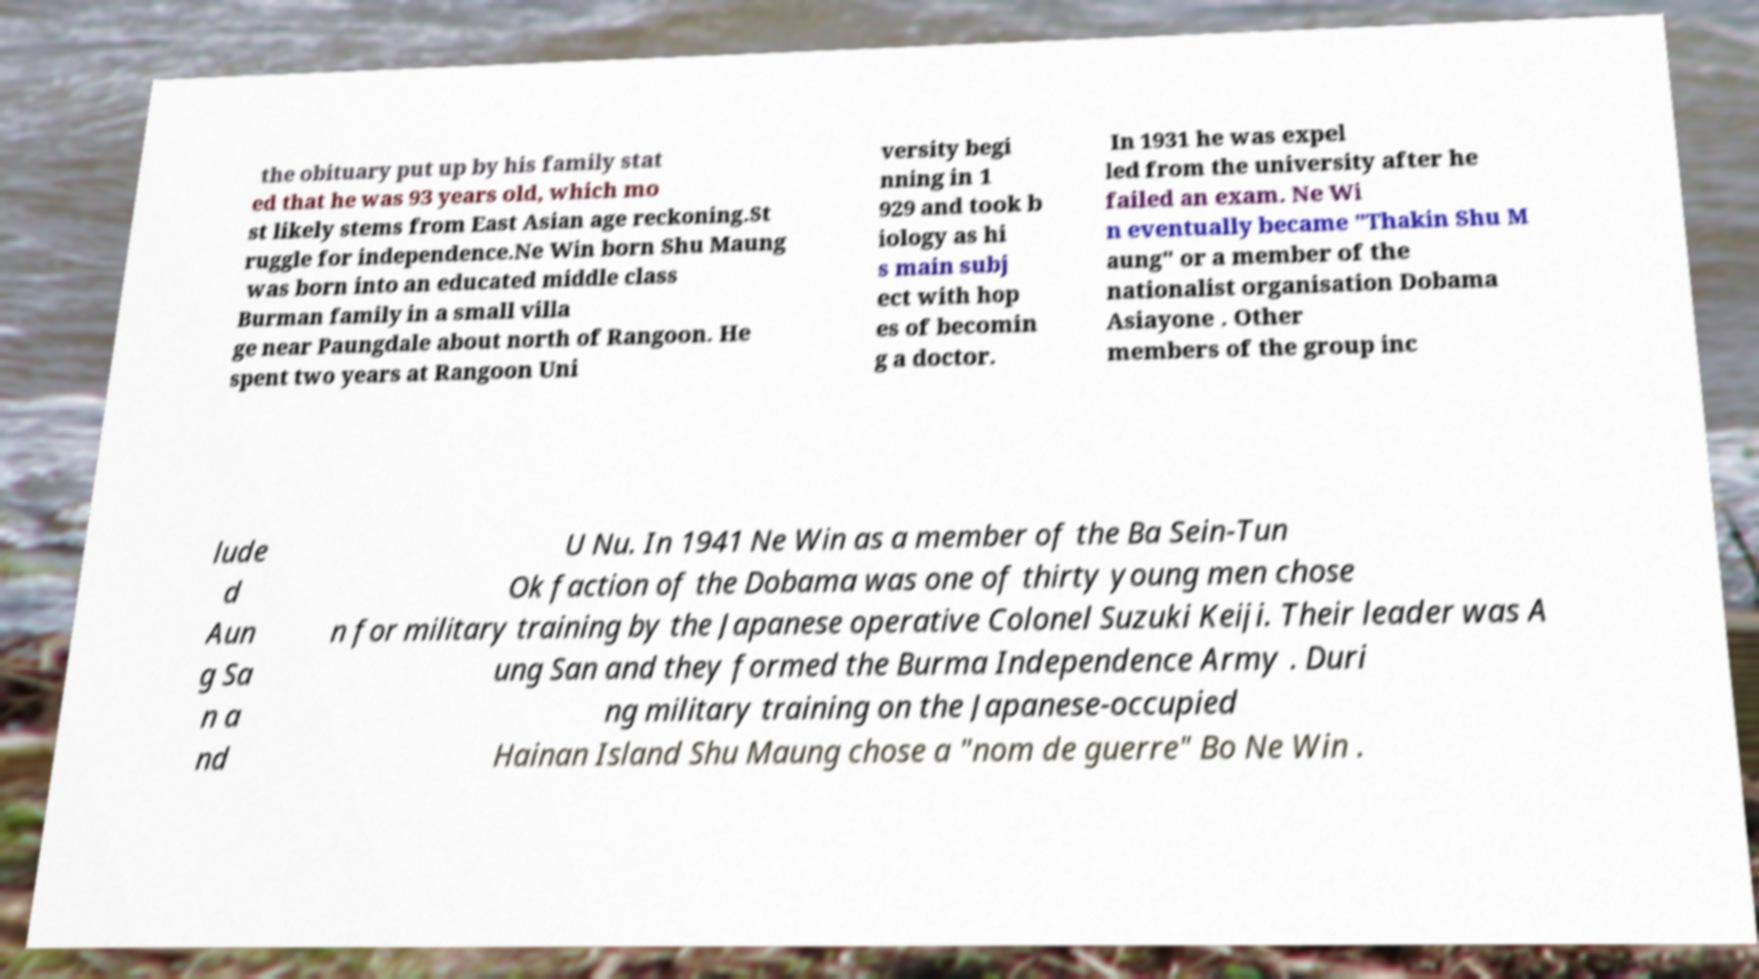Can you accurately transcribe the text from the provided image for me? the obituary put up by his family stat ed that he was 93 years old, which mo st likely stems from East Asian age reckoning.St ruggle for independence.Ne Win born Shu Maung was born into an educated middle class Burman family in a small villa ge near Paungdale about north of Rangoon. He spent two years at Rangoon Uni versity begi nning in 1 929 and took b iology as hi s main subj ect with hop es of becomin g a doctor. In 1931 he was expel led from the university after he failed an exam. Ne Wi n eventually became "Thakin Shu M aung" or a member of the nationalist organisation Dobama Asiayone . Other members of the group inc lude d Aun g Sa n a nd U Nu. In 1941 Ne Win as a member of the Ba Sein-Tun Ok faction of the Dobama was one of thirty young men chose n for military training by the Japanese operative Colonel Suzuki Keiji. Their leader was A ung San and they formed the Burma Independence Army . Duri ng military training on the Japanese-occupied Hainan Island Shu Maung chose a "nom de guerre" Bo Ne Win . 